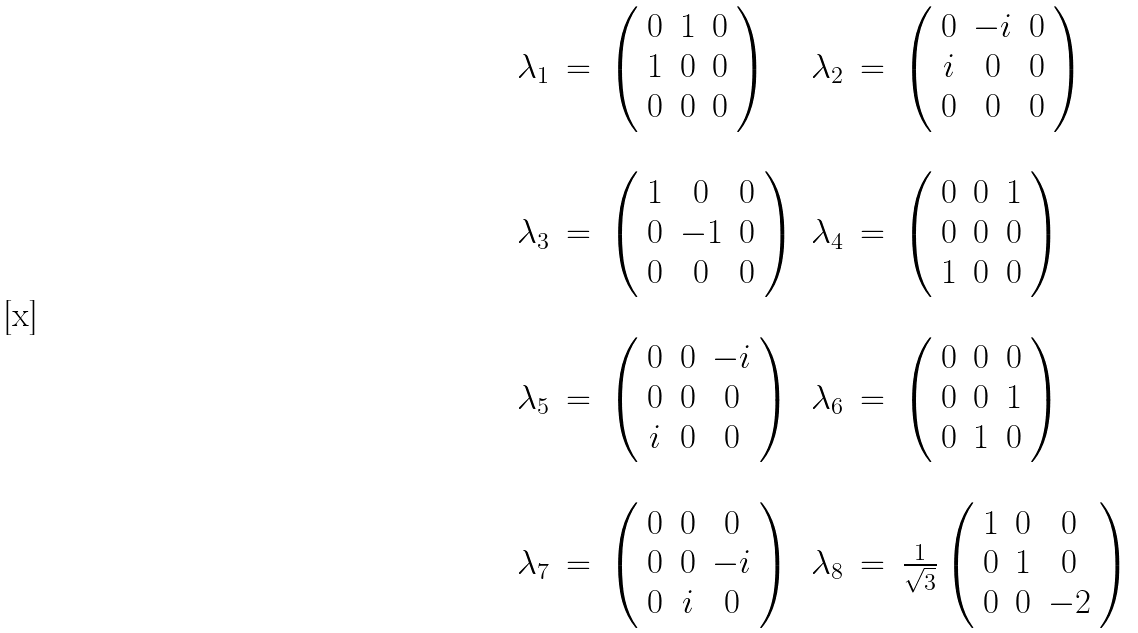Convert formula to latex. <formula><loc_0><loc_0><loc_500><loc_500>\begin{array} { r c l r c l } \lambda _ { 1 } & = & \left ( \begin{array} { c c c } 0 & 1 & 0 \\ 1 & 0 & 0 \\ 0 & 0 & 0 \end{array} \right ) & \lambda _ { 2 } & = & \left ( \begin{array} { c c c } 0 & - i & 0 \\ i & 0 & 0 \\ 0 & 0 & 0 \end{array} \right ) \\ & & & & & \\ \lambda _ { 3 } & = & \left ( \begin{array} { c c c } 1 & 0 & 0 \\ 0 & - 1 & 0 \\ 0 & 0 & 0 \end{array} \right ) & \lambda _ { 4 } & = & \left ( \begin{array} { c c c } 0 & 0 & 1 \\ 0 & 0 & 0 \\ 1 & 0 & 0 \end{array} \right ) \\ & & & & & \\ \lambda _ { 5 } & = & \left ( \begin{array} { c c c } 0 & 0 & - i \\ 0 & 0 & 0 \\ i & 0 & 0 \end{array} \right ) & \lambda _ { 6 } & = & \left ( \begin{array} { c c c } 0 & 0 & 0 \\ 0 & 0 & 1 \\ 0 & 1 & 0 \end{array} \right ) \\ & & & & & \\ \lambda _ { 7 } & = & \left ( \begin{array} { c c c } 0 & 0 & 0 \\ 0 & 0 & - i \\ 0 & i & 0 \end{array} \right ) & \lambda _ { 8 } & = & \frac { 1 } { \sqrt { 3 } } \left ( \begin{array} { c c c } 1 & 0 & 0 \\ 0 & 1 & 0 \\ 0 & 0 & - 2 \end{array} \right ) \end{array}</formula> 